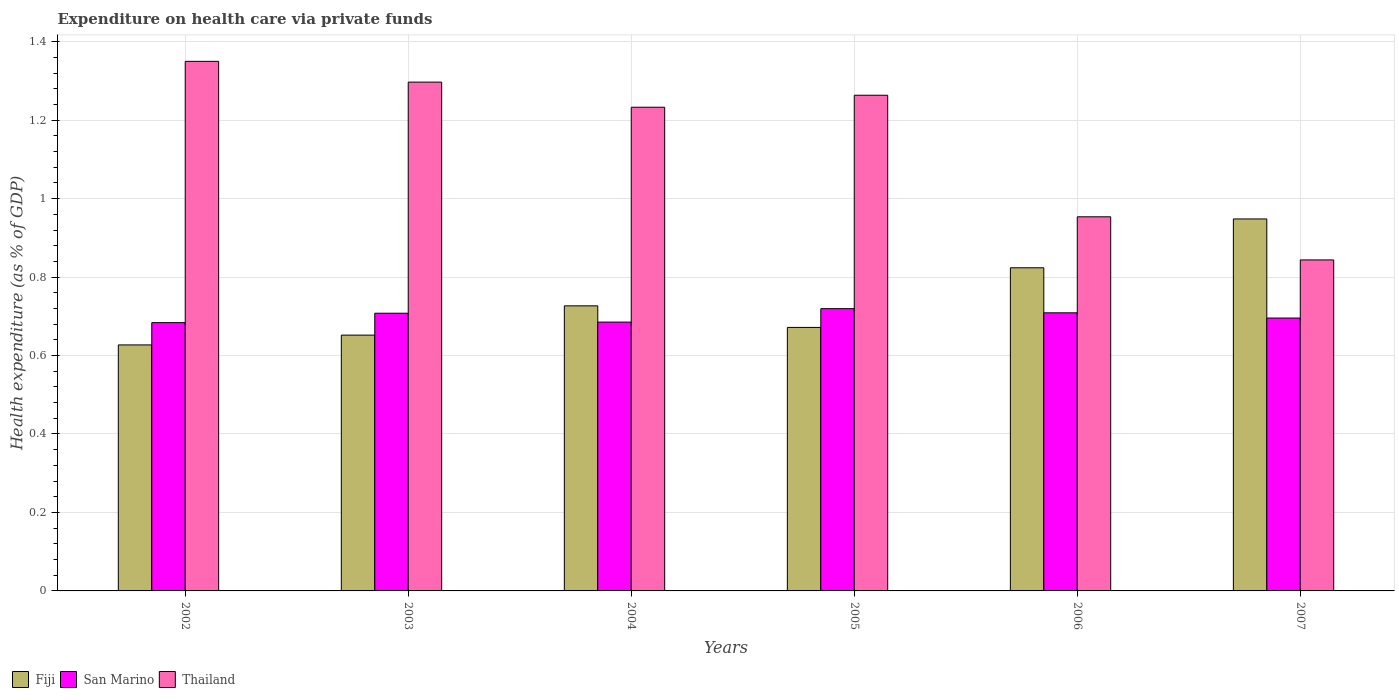How many different coloured bars are there?
Make the answer very short. 3. Are the number of bars per tick equal to the number of legend labels?
Offer a terse response. Yes. Are the number of bars on each tick of the X-axis equal?
Offer a terse response. Yes. What is the label of the 3rd group of bars from the left?
Your response must be concise. 2004. What is the expenditure made on health care in Fiji in 2005?
Your answer should be compact. 0.67. Across all years, what is the maximum expenditure made on health care in San Marino?
Your answer should be very brief. 0.72. Across all years, what is the minimum expenditure made on health care in Thailand?
Ensure brevity in your answer.  0.84. What is the total expenditure made on health care in San Marino in the graph?
Keep it short and to the point. 4.2. What is the difference between the expenditure made on health care in Thailand in 2003 and that in 2004?
Give a very brief answer. 0.06. What is the difference between the expenditure made on health care in Fiji in 2007 and the expenditure made on health care in San Marino in 2003?
Provide a short and direct response. 0.24. What is the average expenditure made on health care in San Marino per year?
Make the answer very short. 0.7. In the year 2004, what is the difference between the expenditure made on health care in Fiji and expenditure made on health care in San Marino?
Make the answer very short. 0.04. In how many years, is the expenditure made on health care in Fiji greater than 1.08 %?
Give a very brief answer. 0. What is the ratio of the expenditure made on health care in Fiji in 2003 to that in 2004?
Your response must be concise. 0.9. Is the expenditure made on health care in San Marino in 2003 less than that in 2004?
Your answer should be very brief. No. What is the difference between the highest and the second highest expenditure made on health care in Thailand?
Make the answer very short. 0.05. What is the difference between the highest and the lowest expenditure made on health care in Thailand?
Your answer should be compact. 0.51. Is the sum of the expenditure made on health care in San Marino in 2002 and 2005 greater than the maximum expenditure made on health care in Fiji across all years?
Give a very brief answer. Yes. What does the 2nd bar from the left in 2006 represents?
Offer a very short reply. San Marino. What does the 2nd bar from the right in 2006 represents?
Your response must be concise. San Marino. How many bars are there?
Provide a short and direct response. 18. Are all the bars in the graph horizontal?
Ensure brevity in your answer.  No. How many years are there in the graph?
Your answer should be very brief. 6. What is the difference between two consecutive major ticks on the Y-axis?
Give a very brief answer. 0.2. Are the values on the major ticks of Y-axis written in scientific E-notation?
Your answer should be very brief. No. Does the graph contain grids?
Your answer should be very brief. Yes. Where does the legend appear in the graph?
Provide a succinct answer. Bottom left. How many legend labels are there?
Ensure brevity in your answer.  3. What is the title of the graph?
Offer a very short reply. Expenditure on health care via private funds. What is the label or title of the X-axis?
Your response must be concise. Years. What is the label or title of the Y-axis?
Offer a terse response. Health expenditure (as % of GDP). What is the Health expenditure (as % of GDP) of Fiji in 2002?
Your response must be concise. 0.63. What is the Health expenditure (as % of GDP) in San Marino in 2002?
Give a very brief answer. 0.68. What is the Health expenditure (as % of GDP) in Thailand in 2002?
Your response must be concise. 1.35. What is the Health expenditure (as % of GDP) of Fiji in 2003?
Give a very brief answer. 0.65. What is the Health expenditure (as % of GDP) of San Marino in 2003?
Keep it short and to the point. 0.71. What is the Health expenditure (as % of GDP) of Thailand in 2003?
Keep it short and to the point. 1.3. What is the Health expenditure (as % of GDP) in Fiji in 2004?
Your answer should be very brief. 0.73. What is the Health expenditure (as % of GDP) of San Marino in 2004?
Keep it short and to the point. 0.69. What is the Health expenditure (as % of GDP) of Thailand in 2004?
Your answer should be very brief. 1.23. What is the Health expenditure (as % of GDP) of Fiji in 2005?
Make the answer very short. 0.67. What is the Health expenditure (as % of GDP) in San Marino in 2005?
Keep it short and to the point. 0.72. What is the Health expenditure (as % of GDP) of Thailand in 2005?
Your answer should be compact. 1.26. What is the Health expenditure (as % of GDP) of Fiji in 2006?
Provide a succinct answer. 0.82. What is the Health expenditure (as % of GDP) in San Marino in 2006?
Ensure brevity in your answer.  0.71. What is the Health expenditure (as % of GDP) of Thailand in 2006?
Your answer should be very brief. 0.95. What is the Health expenditure (as % of GDP) of Fiji in 2007?
Ensure brevity in your answer.  0.95. What is the Health expenditure (as % of GDP) of San Marino in 2007?
Provide a short and direct response. 0.7. What is the Health expenditure (as % of GDP) in Thailand in 2007?
Your response must be concise. 0.84. Across all years, what is the maximum Health expenditure (as % of GDP) of Fiji?
Offer a very short reply. 0.95. Across all years, what is the maximum Health expenditure (as % of GDP) in San Marino?
Keep it short and to the point. 0.72. Across all years, what is the maximum Health expenditure (as % of GDP) in Thailand?
Offer a terse response. 1.35. Across all years, what is the minimum Health expenditure (as % of GDP) of Fiji?
Give a very brief answer. 0.63. Across all years, what is the minimum Health expenditure (as % of GDP) in San Marino?
Give a very brief answer. 0.68. Across all years, what is the minimum Health expenditure (as % of GDP) in Thailand?
Make the answer very short. 0.84. What is the total Health expenditure (as % of GDP) in Fiji in the graph?
Provide a succinct answer. 4.45. What is the total Health expenditure (as % of GDP) of San Marino in the graph?
Provide a succinct answer. 4.2. What is the total Health expenditure (as % of GDP) of Thailand in the graph?
Your answer should be very brief. 6.94. What is the difference between the Health expenditure (as % of GDP) of Fiji in 2002 and that in 2003?
Give a very brief answer. -0.03. What is the difference between the Health expenditure (as % of GDP) of San Marino in 2002 and that in 2003?
Your response must be concise. -0.02. What is the difference between the Health expenditure (as % of GDP) of Thailand in 2002 and that in 2003?
Provide a short and direct response. 0.05. What is the difference between the Health expenditure (as % of GDP) in Fiji in 2002 and that in 2004?
Your answer should be very brief. -0.1. What is the difference between the Health expenditure (as % of GDP) in San Marino in 2002 and that in 2004?
Your answer should be very brief. -0. What is the difference between the Health expenditure (as % of GDP) of Thailand in 2002 and that in 2004?
Your response must be concise. 0.12. What is the difference between the Health expenditure (as % of GDP) of Fiji in 2002 and that in 2005?
Your answer should be very brief. -0.04. What is the difference between the Health expenditure (as % of GDP) in San Marino in 2002 and that in 2005?
Your answer should be compact. -0.04. What is the difference between the Health expenditure (as % of GDP) of Thailand in 2002 and that in 2005?
Give a very brief answer. 0.09. What is the difference between the Health expenditure (as % of GDP) of Fiji in 2002 and that in 2006?
Offer a very short reply. -0.2. What is the difference between the Health expenditure (as % of GDP) in San Marino in 2002 and that in 2006?
Give a very brief answer. -0.03. What is the difference between the Health expenditure (as % of GDP) of Thailand in 2002 and that in 2006?
Your answer should be compact. 0.4. What is the difference between the Health expenditure (as % of GDP) of Fiji in 2002 and that in 2007?
Your answer should be very brief. -0.32. What is the difference between the Health expenditure (as % of GDP) of San Marino in 2002 and that in 2007?
Give a very brief answer. -0.01. What is the difference between the Health expenditure (as % of GDP) of Thailand in 2002 and that in 2007?
Your answer should be compact. 0.51. What is the difference between the Health expenditure (as % of GDP) of Fiji in 2003 and that in 2004?
Your answer should be very brief. -0.07. What is the difference between the Health expenditure (as % of GDP) in San Marino in 2003 and that in 2004?
Offer a terse response. 0.02. What is the difference between the Health expenditure (as % of GDP) of Thailand in 2003 and that in 2004?
Offer a very short reply. 0.06. What is the difference between the Health expenditure (as % of GDP) of Fiji in 2003 and that in 2005?
Keep it short and to the point. -0.02. What is the difference between the Health expenditure (as % of GDP) of San Marino in 2003 and that in 2005?
Your response must be concise. -0.01. What is the difference between the Health expenditure (as % of GDP) of Thailand in 2003 and that in 2005?
Offer a very short reply. 0.03. What is the difference between the Health expenditure (as % of GDP) of Fiji in 2003 and that in 2006?
Provide a succinct answer. -0.17. What is the difference between the Health expenditure (as % of GDP) of San Marino in 2003 and that in 2006?
Make the answer very short. -0. What is the difference between the Health expenditure (as % of GDP) of Thailand in 2003 and that in 2006?
Offer a very short reply. 0.34. What is the difference between the Health expenditure (as % of GDP) of Fiji in 2003 and that in 2007?
Ensure brevity in your answer.  -0.3. What is the difference between the Health expenditure (as % of GDP) of San Marino in 2003 and that in 2007?
Provide a short and direct response. 0.01. What is the difference between the Health expenditure (as % of GDP) in Thailand in 2003 and that in 2007?
Provide a short and direct response. 0.45. What is the difference between the Health expenditure (as % of GDP) in Fiji in 2004 and that in 2005?
Provide a succinct answer. 0.05. What is the difference between the Health expenditure (as % of GDP) in San Marino in 2004 and that in 2005?
Ensure brevity in your answer.  -0.03. What is the difference between the Health expenditure (as % of GDP) of Thailand in 2004 and that in 2005?
Offer a terse response. -0.03. What is the difference between the Health expenditure (as % of GDP) in Fiji in 2004 and that in 2006?
Provide a succinct answer. -0.1. What is the difference between the Health expenditure (as % of GDP) in San Marino in 2004 and that in 2006?
Offer a terse response. -0.02. What is the difference between the Health expenditure (as % of GDP) of Thailand in 2004 and that in 2006?
Make the answer very short. 0.28. What is the difference between the Health expenditure (as % of GDP) in Fiji in 2004 and that in 2007?
Offer a terse response. -0.22. What is the difference between the Health expenditure (as % of GDP) in San Marino in 2004 and that in 2007?
Provide a short and direct response. -0.01. What is the difference between the Health expenditure (as % of GDP) of Thailand in 2004 and that in 2007?
Your response must be concise. 0.39. What is the difference between the Health expenditure (as % of GDP) of Fiji in 2005 and that in 2006?
Your answer should be compact. -0.15. What is the difference between the Health expenditure (as % of GDP) of San Marino in 2005 and that in 2006?
Provide a succinct answer. 0.01. What is the difference between the Health expenditure (as % of GDP) of Thailand in 2005 and that in 2006?
Your answer should be very brief. 0.31. What is the difference between the Health expenditure (as % of GDP) of Fiji in 2005 and that in 2007?
Offer a terse response. -0.28. What is the difference between the Health expenditure (as % of GDP) of San Marino in 2005 and that in 2007?
Your answer should be compact. 0.02. What is the difference between the Health expenditure (as % of GDP) of Thailand in 2005 and that in 2007?
Provide a short and direct response. 0.42. What is the difference between the Health expenditure (as % of GDP) of Fiji in 2006 and that in 2007?
Give a very brief answer. -0.12. What is the difference between the Health expenditure (as % of GDP) in San Marino in 2006 and that in 2007?
Keep it short and to the point. 0.01. What is the difference between the Health expenditure (as % of GDP) of Thailand in 2006 and that in 2007?
Make the answer very short. 0.11. What is the difference between the Health expenditure (as % of GDP) in Fiji in 2002 and the Health expenditure (as % of GDP) in San Marino in 2003?
Your answer should be very brief. -0.08. What is the difference between the Health expenditure (as % of GDP) of Fiji in 2002 and the Health expenditure (as % of GDP) of Thailand in 2003?
Your answer should be very brief. -0.67. What is the difference between the Health expenditure (as % of GDP) in San Marino in 2002 and the Health expenditure (as % of GDP) in Thailand in 2003?
Give a very brief answer. -0.61. What is the difference between the Health expenditure (as % of GDP) in Fiji in 2002 and the Health expenditure (as % of GDP) in San Marino in 2004?
Your response must be concise. -0.06. What is the difference between the Health expenditure (as % of GDP) in Fiji in 2002 and the Health expenditure (as % of GDP) in Thailand in 2004?
Keep it short and to the point. -0.61. What is the difference between the Health expenditure (as % of GDP) in San Marino in 2002 and the Health expenditure (as % of GDP) in Thailand in 2004?
Provide a succinct answer. -0.55. What is the difference between the Health expenditure (as % of GDP) in Fiji in 2002 and the Health expenditure (as % of GDP) in San Marino in 2005?
Offer a very short reply. -0.09. What is the difference between the Health expenditure (as % of GDP) of Fiji in 2002 and the Health expenditure (as % of GDP) of Thailand in 2005?
Provide a short and direct response. -0.64. What is the difference between the Health expenditure (as % of GDP) of San Marino in 2002 and the Health expenditure (as % of GDP) of Thailand in 2005?
Keep it short and to the point. -0.58. What is the difference between the Health expenditure (as % of GDP) of Fiji in 2002 and the Health expenditure (as % of GDP) of San Marino in 2006?
Give a very brief answer. -0.08. What is the difference between the Health expenditure (as % of GDP) in Fiji in 2002 and the Health expenditure (as % of GDP) in Thailand in 2006?
Provide a short and direct response. -0.33. What is the difference between the Health expenditure (as % of GDP) of San Marino in 2002 and the Health expenditure (as % of GDP) of Thailand in 2006?
Your answer should be compact. -0.27. What is the difference between the Health expenditure (as % of GDP) of Fiji in 2002 and the Health expenditure (as % of GDP) of San Marino in 2007?
Keep it short and to the point. -0.07. What is the difference between the Health expenditure (as % of GDP) of Fiji in 2002 and the Health expenditure (as % of GDP) of Thailand in 2007?
Your answer should be very brief. -0.22. What is the difference between the Health expenditure (as % of GDP) of San Marino in 2002 and the Health expenditure (as % of GDP) of Thailand in 2007?
Your response must be concise. -0.16. What is the difference between the Health expenditure (as % of GDP) in Fiji in 2003 and the Health expenditure (as % of GDP) in San Marino in 2004?
Give a very brief answer. -0.03. What is the difference between the Health expenditure (as % of GDP) of Fiji in 2003 and the Health expenditure (as % of GDP) of Thailand in 2004?
Your answer should be very brief. -0.58. What is the difference between the Health expenditure (as % of GDP) of San Marino in 2003 and the Health expenditure (as % of GDP) of Thailand in 2004?
Make the answer very short. -0.53. What is the difference between the Health expenditure (as % of GDP) of Fiji in 2003 and the Health expenditure (as % of GDP) of San Marino in 2005?
Provide a short and direct response. -0.07. What is the difference between the Health expenditure (as % of GDP) in Fiji in 2003 and the Health expenditure (as % of GDP) in Thailand in 2005?
Make the answer very short. -0.61. What is the difference between the Health expenditure (as % of GDP) in San Marino in 2003 and the Health expenditure (as % of GDP) in Thailand in 2005?
Ensure brevity in your answer.  -0.56. What is the difference between the Health expenditure (as % of GDP) in Fiji in 2003 and the Health expenditure (as % of GDP) in San Marino in 2006?
Your answer should be compact. -0.06. What is the difference between the Health expenditure (as % of GDP) of Fiji in 2003 and the Health expenditure (as % of GDP) of Thailand in 2006?
Your answer should be very brief. -0.3. What is the difference between the Health expenditure (as % of GDP) of San Marino in 2003 and the Health expenditure (as % of GDP) of Thailand in 2006?
Ensure brevity in your answer.  -0.25. What is the difference between the Health expenditure (as % of GDP) of Fiji in 2003 and the Health expenditure (as % of GDP) of San Marino in 2007?
Offer a terse response. -0.04. What is the difference between the Health expenditure (as % of GDP) of Fiji in 2003 and the Health expenditure (as % of GDP) of Thailand in 2007?
Make the answer very short. -0.19. What is the difference between the Health expenditure (as % of GDP) in San Marino in 2003 and the Health expenditure (as % of GDP) in Thailand in 2007?
Provide a succinct answer. -0.14. What is the difference between the Health expenditure (as % of GDP) of Fiji in 2004 and the Health expenditure (as % of GDP) of San Marino in 2005?
Give a very brief answer. 0.01. What is the difference between the Health expenditure (as % of GDP) of Fiji in 2004 and the Health expenditure (as % of GDP) of Thailand in 2005?
Provide a succinct answer. -0.54. What is the difference between the Health expenditure (as % of GDP) of San Marino in 2004 and the Health expenditure (as % of GDP) of Thailand in 2005?
Provide a short and direct response. -0.58. What is the difference between the Health expenditure (as % of GDP) in Fiji in 2004 and the Health expenditure (as % of GDP) in San Marino in 2006?
Your response must be concise. 0.02. What is the difference between the Health expenditure (as % of GDP) of Fiji in 2004 and the Health expenditure (as % of GDP) of Thailand in 2006?
Make the answer very short. -0.23. What is the difference between the Health expenditure (as % of GDP) of San Marino in 2004 and the Health expenditure (as % of GDP) of Thailand in 2006?
Provide a short and direct response. -0.27. What is the difference between the Health expenditure (as % of GDP) in Fiji in 2004 and the Health expenditure (as % of GDP) in San Marino in 2007?
Make the answer very short. 0.03. What is the difference between the Health expenditure (as % of GDP) of Fiji in 2004 and the Health expenditure (as % of GDP) of Thailand in 2007?
Your response must be concise. -0.12. What is the difference between the Health expenditure (as % of GDP) of San Marino in 2004 and the Health expenditure (as % of GDP) of Thailand in 2007?
Provide a succinct answer. -0.16. What is the difference between the Health expenditure (as % of GDP) in Fiji in 2005 and the Health expenditure (as % of GDP) in San Marino in 2006?
Give a very brief answer. -0.04. What is the difference between the Health expenditure (as % of GDP) in Fiji in 2005 and the Health expenditure (as % of GDP) in Thailand in 2006?
Keep it short and to the point. -0.28. What is the difference between the Health expenditure (as % of GDP) of San Marino in 2005 and the Health expenditure (as % of GDP) of Thailand in 2006?
Make the answer very short. -0.23. What is the difference between the Health expenditure (as % of GDP) of Fiji in 2005 and the Health expenditure (as % of GDP) of San Marino in 2007?
Keep it short and to the point. -0.02. What is the difference between the Health expenditure (as % of GDP) of Fiji in 2005 and the Health expenditure (as % of GDP) of Thailand in 2007?
Provide a succinct answer. -0.17. What is the difference between the Health expenditure (as % of GDP) in San Marino in 2005 and the Health expenditure (as % of GDP) in Thailand in 2007?
Offer a terse response. -0.12. What is the difference between the Health expenditure (as % of GDP) of Fiji in 2006 and the Health expenditure (as % of GDP) of San Marino in 2007?
Give a very brief answer. 0.13. What is the difference between the Health expenditure (as % of GDP) in Fiji in 2006 and the Health expenditure (as % of GDP) in Thailand in 2007?
Your response must be concise. -0.02. What is the difference between the Health expenditure (as % of GDP) of San Marino in 2006 and the Health expenditure (as % of GDP) of Thailand in 2007?
Ensure brevity in your answer.  -0.13. What is the average Health expenditure (as % of GDP) of Fiji per year?
Keep it short and to the point. 0.74. What is the average Health expenditure (as % of GDP) of San Marino per year?
Make the answer very short. 0.7. What is the average Health expenditure (as % of GDP) in Thailand per year?
Make the answer very short. 1.16. In the year 2002, what is the difference between the Health expenditure (as % of GDP) in Fiji and Health expenditure (as % of GDP) in San Marino?
Offer a very short reply. -0.06. In the year 2002, what is the difference between the Health expenditure (as % of GDP) in Fiji and Health expenditure (as % of GDP) in Thailand?
Your answer should be very brief. -0.72. In the year 2002, what is the difference between the Health expenditure (as % of GDP) of San Marino and Health expenditure (as % of GDP) of Thailand?
Offer a very short reply. -0.67. In the year 2003, what is the difference between the Health expenditure (as % of GDP) in Fiji and Health expenditure (as % of GDP) in San Marino?
Give a very brief answer. -0.06. In the year 2003, what is the difference between the Health expenditure (as % of GDP) in Fiji and Health expenditure (as % of GDP) in Thailand?
Ensure brevity in your answer.  -0.64. In the year 2003, what is the difference between the Health expenditure (as % of GDP) in San Marino and Health expenditure (as % of GDP) in Thailand?
Offer a terse response. -0.59. In the year 2004, what is the difference between the Health expenditure (as % of GDP) in Fiji and Health expenditure (as % of GDP) in San Marino?
Ensure brevity in your answer.  0.04. In the year 2004, what is the difference between the Health expenditure (as % of GDP) of Fiji and Health expenditure (as % of GDP) of Thailand?
Offer a terse response. -0.51. In the year 2004, what is the difference between the Health expenditure (as % of GDP) of San Marino and Health expenditure (as % of GDP) of Thailand?
Your answer should be compact. -0.55. In the year 2005, what is the difference between the Health expenditure (as % of GDP) of Fiji and Health expenditure (as % of GDP) of San Marino?
Your response must be concise. -0.05. In the year 2005, what is the difference between the Health expenditure (as % of GDP) in Fiji and Health expenditure (as % of GDP) in Thailand?
Ensure brevity in your answer.  -0.59. In the year 2005, what is the difference between the Health expenditure (as % of GDP) in San Marino and Health expenditure (as % of GDP) in Thailand?
Your answer should be very brief. -0.54. In the year 2006, what is the difference between the Health expenditure (as % of GDP) of Fiji and Health expenditure (as % of GDP) of San Marino?
Give a very brief answer. 0.11. In the year 2006, what is the difference between the Health expenditure (as % of GDP) in Fiji and Health expenditure (as % of GDP) in Thailand?
Make the answer very short. -0.13. In the year 2006, what is the difference between the Health expenditure (as % of GDP) in San Marino and Health expenditure (as % of GDP) in Thailand?
Ensure brevity in your answer.  -0.24. In the year 2007, what is the difference between the Health expenditure (as % of GDP) in Fiji and Health expenditure (as % of GDP) in San Marino?
Give a very brief answer. 0.25. In the year 2007, what is the difference between the Health expenditure (as % of GDP) in Fiji and Health expenditure (as % of GDP) in Thailand?
Offer a terse response. 0.1. In the year 2007, what is the difference between the Health expenditure (as % of GDP) of San Marino and Health expenditure (as % of GDP) of Thailand?
Your answer should be very brief. -0.15. What is the ratio of the Health expenditure (as % of GDP) in Fiji in 2002 to that in 2003?
Provide a succinct answer. 0.96. What is the ratio of the Health expenditure (as % of GDP) of San Marino in 2002 to that in 2003?
Your answer should be compact. 0.97. What is the ratio of the Health expenditure (as % of GDP) of Thailand in 2002 to that in 2003?
Offer a terse response. 1.04. What is the ratio of the Health expenditure (as % of GDP) in Fiji in 2002 to that in 2004?
Your answer should be compact. 0.86. What is the ratio of the Health expenditure (as % of GDP) of San Marino in 2002 to that in 2004?
Your answer should be compact. 1. What is the ratio of the Health expenditure (as % of GDP) of Thailand in 2002 to that in 2004?
Ensure brevity in your answer.  1.09. What is the ratio of the Health expenditure (as % of GDP) in Fiji in 2002 to that in 2005?
Your response must be concise. 0.93. What is the ratio of the Health expenditure (as % of GDP) in San Marino in 2002 to that in 2005?
Keep it short and to the point. 0.95. What is the ratio of the Health expenditure (as % of GDP) of Thailand in 2002 to that in 2005?
Your response must be concise. 1.07. What is the ratio of the Health expenditure (as % of GDP) in Fiji in 2002 to that in 2006?
Your answer should be compact. 0.76. What is the ratio of the Health expenditure (as % of GDP) in San Marino in 2002 to that in 2006?
Offer a terse response. 0.96. What is the ratio of the Health expenditure (as % of GDP) of Thailand in 2002 to that in 2006?
Make the answer very short. 1.42. What is the ratio of the Health expenditure (as % of GDP) in Fiji in 2002 to that in 2007?
Your answer should be very brief. 0.66. What is the ratio of the Health expenditure (as % of GDP) of San Marino in 2002 to that in 2007?
Give a very brief answer. 0.98. What is the ratio of the Health expenditure (as % of GDP) in Thailand in 2002 to that in 2007?
Offer a very short reply. 1.6. What is the ratio of the Health expenditure (as % of GDP) of Fiji in 2003 to that in 2004?
Offer a very short reply. 0.9. What is the ratio of the Health expenditure (as % of GDP) in San Marino in 2003 to that in 2004?
Make the answer very short. 1.03. What is the ratio of the Health expenditure (as % of GDP) of Thailand in 2003 to that in 2004?
Offer a very short reply. 1.05. What is the ratio of the Health expenditure (as % of GDP) of Fiji in 2003 to that in 2005?
Your answer should be compact. 0.97. What is the ratio of the Health expenditure (as % of GDP) of San Marino in 2003 to that in 2005?
Provide a short and direct response. 0.98. What is the ratio of the Health expenditure (as % of GDP) of Thailand in 2003 to that in 2005?
Your answer should be compact. 1.03. What is the ratio of the Health expenditure (as % of GDP) of Fiji in 2003 to that in 2006?
Your response must be concise. 0.79. What is the ratio of the Health expenditure (as % of GDP) of San Marino in 2003 to that in 2006?
Give a very brief answer. 1. What is the ratio of the Health expenditure (as % of GDP) in Thailand in 2003 to that in 2006?
Your response must be concise. 1.36. What is the ratio of the Health expenditure (as % of GDP) of Fiji in 2003 to that in 2007?
Your answer should be compact. 0.69. What is the ratio of the Health expenditure (as % of GDP) in San Marino in 2003 to that in 2007?
Make the answer very short. 1.02. What is the ratio of the Health expenditure (as % of GDP) in Thailand in 2003 to that in 2007?
Your answer should be compact. 1.54. What is the ratio of the Health expenditure (as % of GDP) of Fiji in 2004 to that in 2005?
Offer a very short reply. 1.08. What is the ratio of the Health expenditure (as % of GDP) of Thailand in 2004 to that in 2005?
Your answer should be compact. 0.98. What is the ratio of the Health expenditure (as % of GDP) of Fiji in 2004 to that in 2006?
Give a very brief answer. 0.88. What is the ratio of the Health expenditure (as % of GDP) in San Marino in 2004 to that in 2006?
Your answer should be compact. 0.97. What is the ratio of the Health expenditure (as % of GDP) of Thailand in 2004 to that in 2006?
Offer a very short reply. 1.29. What is the ratio of the Health expenditure (as % of GDP) of Fiji in 2004 to that in 2007?
Your answer should be very brief. 0.77. What is the ratio of the Health expenditure (as % of GDP) in San Marino in 2004 to that in 2007?
Offer a very short reply. 0.99. What is the ratio of the Health expenditure (as % of GDP) of Thailand in 2004 to that in 2007?
Your answer should be compact. 1.46. What is the ratio of the Health expenditure (as % of GDP) of Fiji in 2005 to that in 2006?
Ensure brevity in your answer.  0.82. What is the ratio of the Health expenditure (as % of GDP) of Thailand in 2005 to that in 2006?
Keep it short and to the point. 1.32. What is the ratio of the Health expenditure (as % of GDP) of Fiji in 2005 to that in 2007?
Offer a terse response. 0.71. What is the ratio of the Health expenditure (as % of GDP) in San Marino in 2005 to that in 2007?
Your response must be concise. 1.03. What is the ratio of the Health expenditure (as % of GDP) of Thailand in 2005 to that in 2007?
Offer a terse response. 1.5. What is the ratio of the Health expenditure (as % of GDP) of Fiji in 2006 to that in 2007?
Your answer should be very brief. 0.87. What is the ratio of the Health expenditure (as % of GDP) in San Marino in 2006 to that in 2007?
Provide a short and direct response. 1.02. What is the ratio of the Health expenditure (as % of GDP) of Thailand in 2006 to that in 2007?
Make the answer very short. 1.13. What is the difference between the highest and the second highest Health expenditure (as % of GDP) in Fiji?
Offer a very short reply. 0.12. What is the difference between the highest and the second highest Health expenditure (as % of GDP) of San Marino?
Your response must be concise. 0.01. What is the difference between the highest and the second highest Health expenditure (as % of GDP) of Thailand?
Your response must be concise. 0.05. What is the difference between the highest and the lowest Health expenditure (as % of GDP) of Fiji?
Your response must be concise. 0.32. What is the difference between the highest and the lowest Health expenditure (as % of GDP) in San Marino?
Give a very brief answer. 0.04. What is the difference between the highest and the lowest Health expenditure (as % of GDP) in Thailand?
Keep it short and to the point. 0.51. 